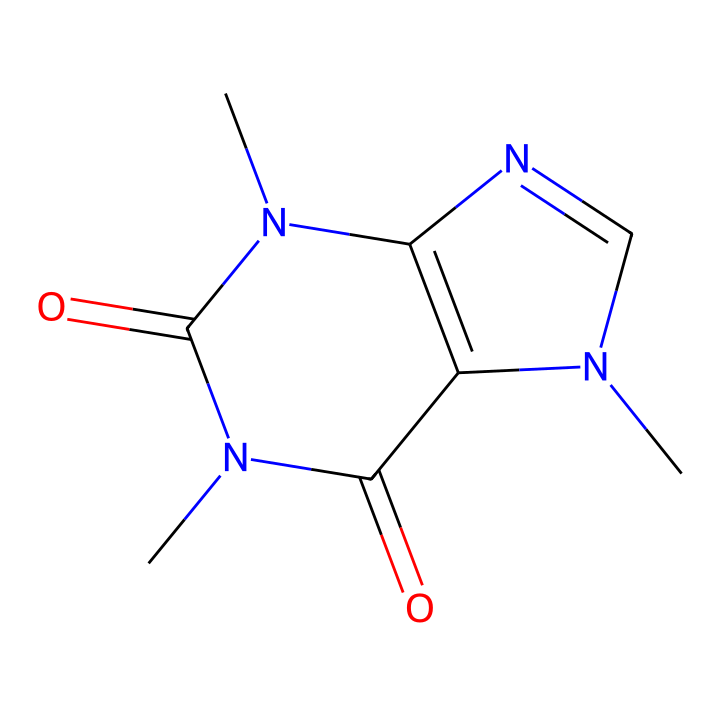How many nitrogen atoms are present in this structure? When observing the SMILES representation, we can count the nitrogen symbols 'N'. There are two instances of 'N' indicating that there are two nitrogen atoms in the structure.
Answer: 2 What is the total number of carbon atoms in this chemical structure? By analyzing the SMILES code, we identify the carbon atoms represented by the 'C' in the structure. There are a total of 8 carbon atoms present when counting.
Answer: 8 Which functional groups are present in caffeine based on its structure? Caffeine has two carbonyl groups (C=O), represented by 'C(=O)', and two nitrogen atoms contributing to the amine functional group. This means we observe both carbonyl and amine functional groups.
Answer: carbonyl and amine Is this chemical structure aromatic? To determine if caffeine is aromatic, we identify the presence of stabilizing resonance in cyclic structures. The presence of nitrogen atoms and the arrangement of carbon atoms suggest a resonance-stabilized system indicative of aromatic characteristics.
Answer: yes What type of chemical compound is caffeine classified as based on its structure? Caffeine is classified as an alkaloid due to the presence of nitrogen heteroatoms within a heterocyclic structure, which is characteristic of many alkaloids.
Answer: alkaloid How many rings are present in the structure of caffeine? By analyzing the ring closures indicated in the SMILES, we find that there are two cyclic structures formed, hence caffeine contains two rings in its molecular structure.
Answer: 2 What is the implications of the carbon-to-nitrogen ratio in regards to caffeine’s properties? The carbon-to-nitrogen ratio is a significant indicator of the balance between hydrocarbons and nitrogenous compounds, with caffeine having a ratio of 4:1, suggesting it retains stimulant properties common to alkaloids while maintaining a relatively stable structure.
Answer: 4:1 